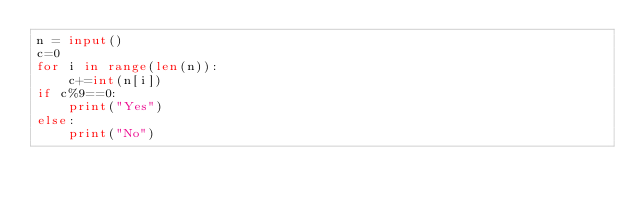<code> <loc_0><loc_0><loc_500><loc_500><_Python_>n = input()
c=0
for i in range(len(n)):
    c+=int(n[i])
if c%9==0:
    print("Yes")
else:
    print("No")</code> 